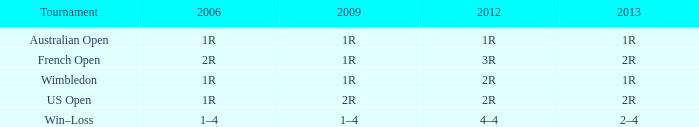What is the 2006 when the 2013 is 1r, and the 2012 is 1r? 1R. 